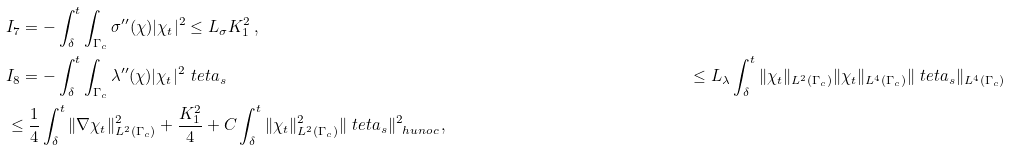Convert formula to latex. <formula><loc_0><loc_0><loc_500><loc_500>& I _ { 7 } = - \int _ { \delta } ^ { t } \int _ { \Gamma _ { c } } \sigma { ^ { \prime \prime } } ( \chi ) | \chi _ { t } | ^ { 2 } \leq L _ { \sigma } K _ { 1 } ^ { 2 } \, , \\ & I _ { 8 } = - \int _ { \delta } ^ { t } \int _ { \Gamma _ { c } } \lambda { ^ { \prime \prime } } ( \chi ) | \chi _ { t } | ^ { 2 } \ t e t a _ { s } & \leq L _ { \lambda } \int _ { \delta } ^ { t } \| \chi _ { t } \| _ { L ^ { 2 } ( \Gamma _ { c } ) } \| \chi _ { t } \| _ { L ^ { 4 } ( \Gamma _ { c } ) } \| \ t e t a _ { s } \| _ { L ^ { 4 } ( \Gamma _ { c } ) } \\ & \leq \frac { 1 } { 4 } \int _ { \delta } ^ { t } \| \nabla \chi _ { t } \| _ { L ^ { 2 } ( \Gamma _ { c } ) } ^ { 2 } + \frac { K _ { 1 } ^ { 2 } } 4 + C \int _ { \delta } ^ { t } \| \chi _ { t } \| _ { L ^ { 2 } ( \Gamma _ { c } ) } ^ { 2 } \| \ t e t a _ { s } \| _ { \ h u n o c } ^ { 2 } \, ,</formula> 